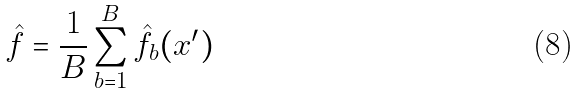<formula> <loc_0><loc_0><loc_500><loc_500>\hat { f } = \frac { 1 } { B } \sum _ { b = 1 } ^ { B } \hat { f } _ { b } ( x ^ { \prime } )</formula> 